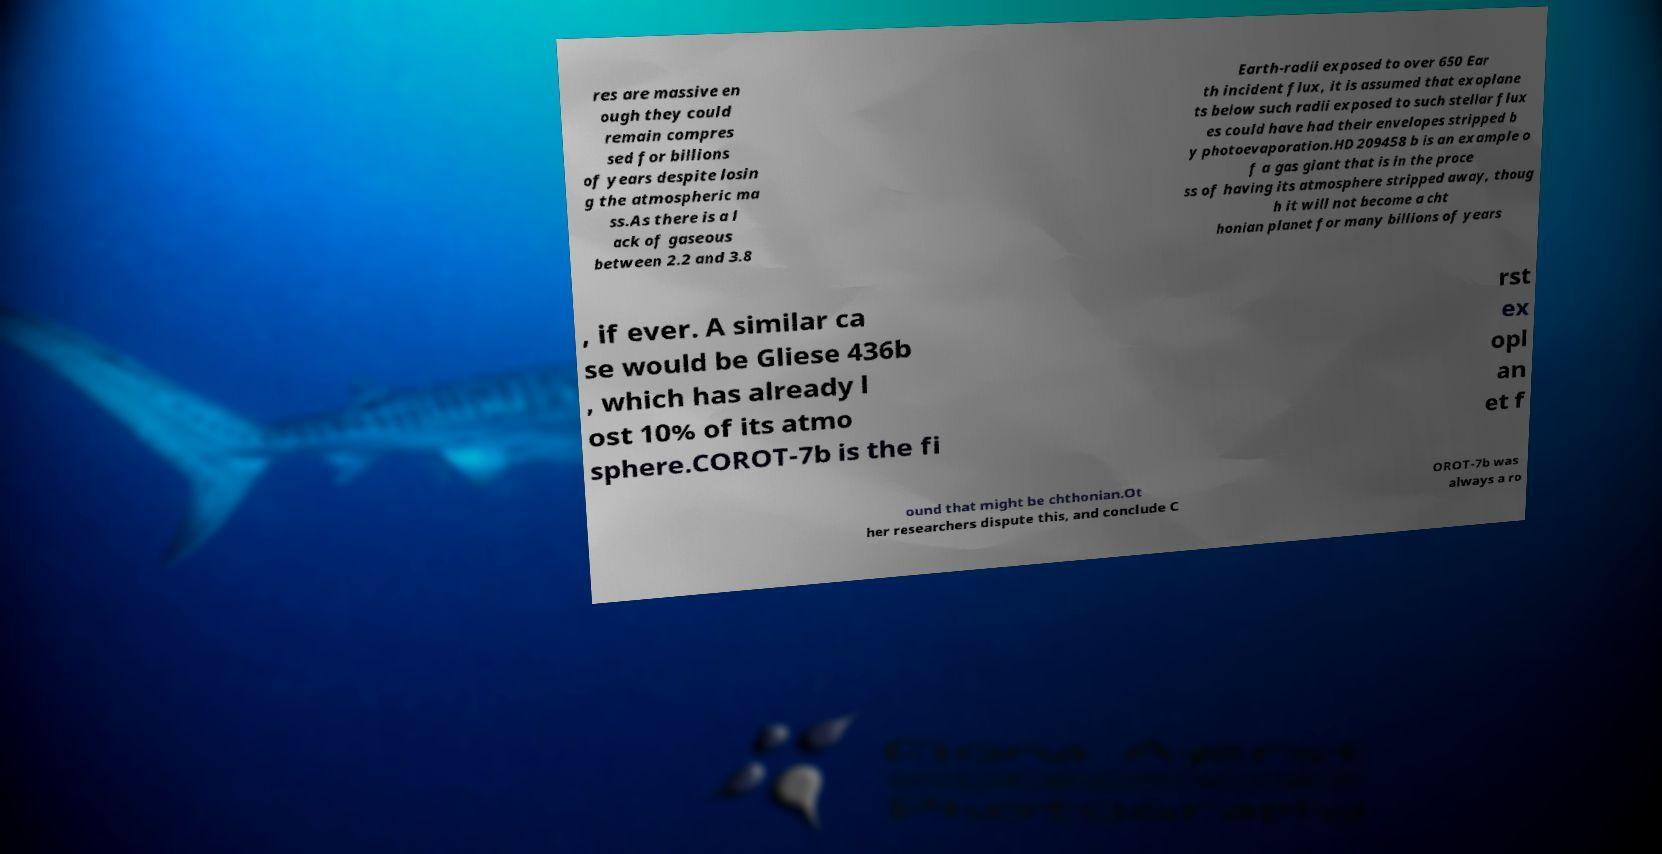Could you extract and type out the text from this image? res are massive en ough they could remain compres sed for billions of years despite losin g the atmospheric ma ss.As there is a l ack of gaseous between 2.2 and 3.8 Earth-radii exposed to over 650 Ear th incident flux, it is assumed that exoplane ts below such radii exposed to such stellar flux es could have had their envelopes stripped b y photoevaporation.HD 209458 b is an example o f a gas giant that is in the proce ss of having its atmosphere stripped away, thoug h it will not become a cht honian planet for many billions of years , if ever. A similar ca se would be Gliese 436b , which has already l ost 10% of its atmo sphere.COROT-7b is the fi rst ex opl an et f ound that might be chthonian.Ot her researchers dispute this, and conclude C OROT-7b was always a ro 